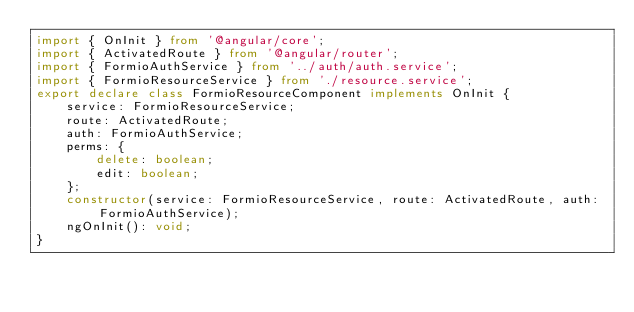<code> <loc_0><loc_0><loc_500><loc_500><_TypeScript_>import { OnInit } from '@angular/core';
import { ActivatedRoute } from '@angular/router';
import { FormioAuthService } from '../auth/auth.service';
import { FormioResourceService } from './resource.service';
export declare class FormioResourceComponent implements OnInit {
    service: FormioResourceService;
    route: ActivatedRoute;
    auth: FormioAuthService;
    perms: {
        delete: boolean;
        edit: boolean;
    };
    constructor(service: FormioResourceService, route: ActivatedRoute, auth: FormioAuthService);
    ngOnInit(): void;
}
</code> 